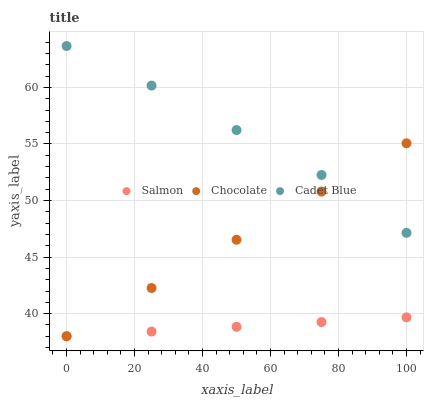Does Salmon have the minimum area under the curve?
Answer yes or no. Yes. Does Cadet Blue have the maximum area under the curve?
Answer yes or no. Yes. Does Chocolate have the minimum area under the curve?
Answer yes or no. No. Does Chocolate have the maximum area under the curve?
Answer yes or no. No. Is Chocolate the smoothest?
Answer yes or no. Yes. Is Cadet Blue the roughest?
Answer yes or no. Yes. Is Salmon the smoothest?
Answer yes or no. No. Is Salmon the roughest?
Answer yes or no. No. Does Salmon have the lowest value?
Answer yes or no. Yes. Does Cadet Blue have the highest value?
Answer yes or no. Yes. Does Chocolate have the highest value?
Answer yes or no. No. Is Salmon less than Cadet Blue?
Answer yes or no. Yes. Is Cadet Blue greater than Salmon?
Answer yes or no. Yes. Does Cadet Blue intersect Chocolate?
Answer yes or no. Yes. Is Cadet Blue less than Chocolate?
Answer yes or no. No. Is Cadet Blue greater than Chocolate?
Answer yes or no. No. Does Salmon intersect Cadet Blue?
Answer yes or no. No. 